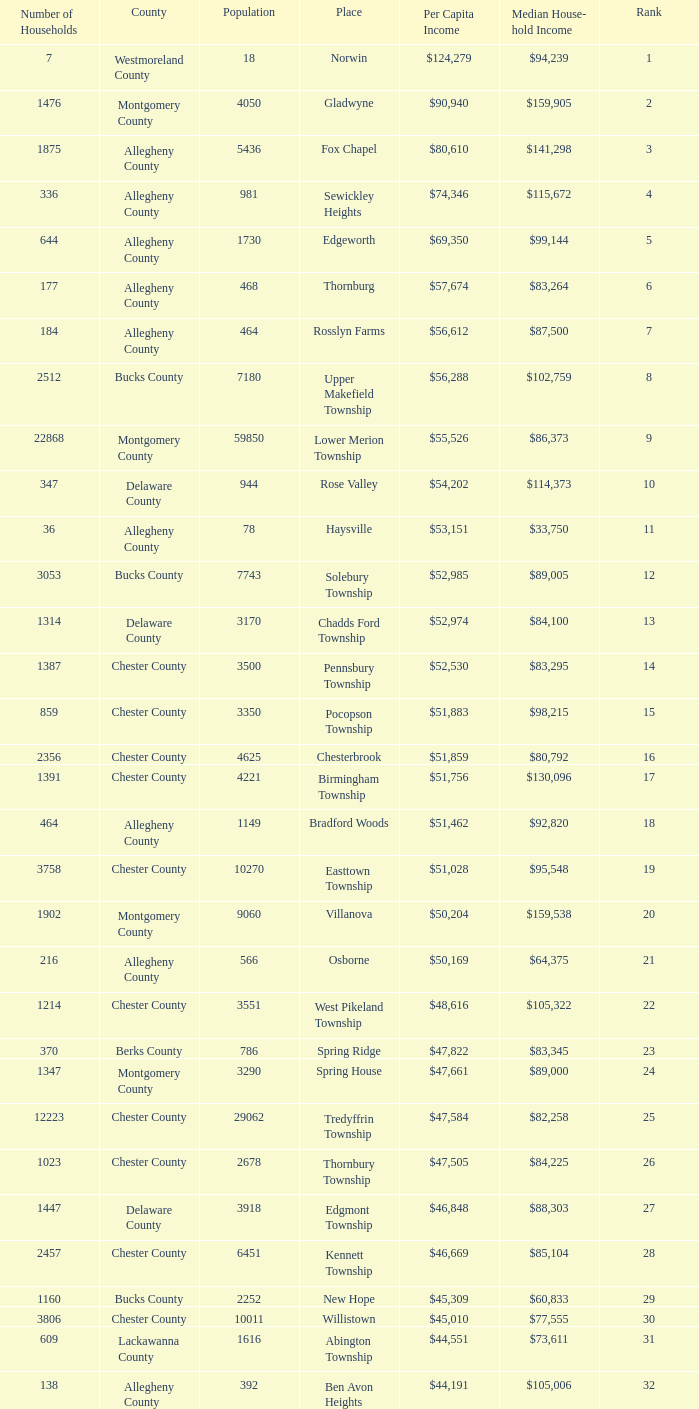What is the per capita income for Fayette County? $42,131. 